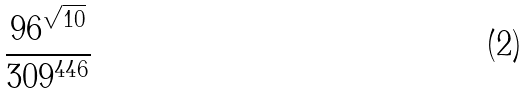<formula> <loc_0><loc_0><loc_500><loc_500>\frac { 9 6 ^ { \sqrt { 1 0 } } } { 3 0 9 ^ { 4 4 6 } }</formula> 